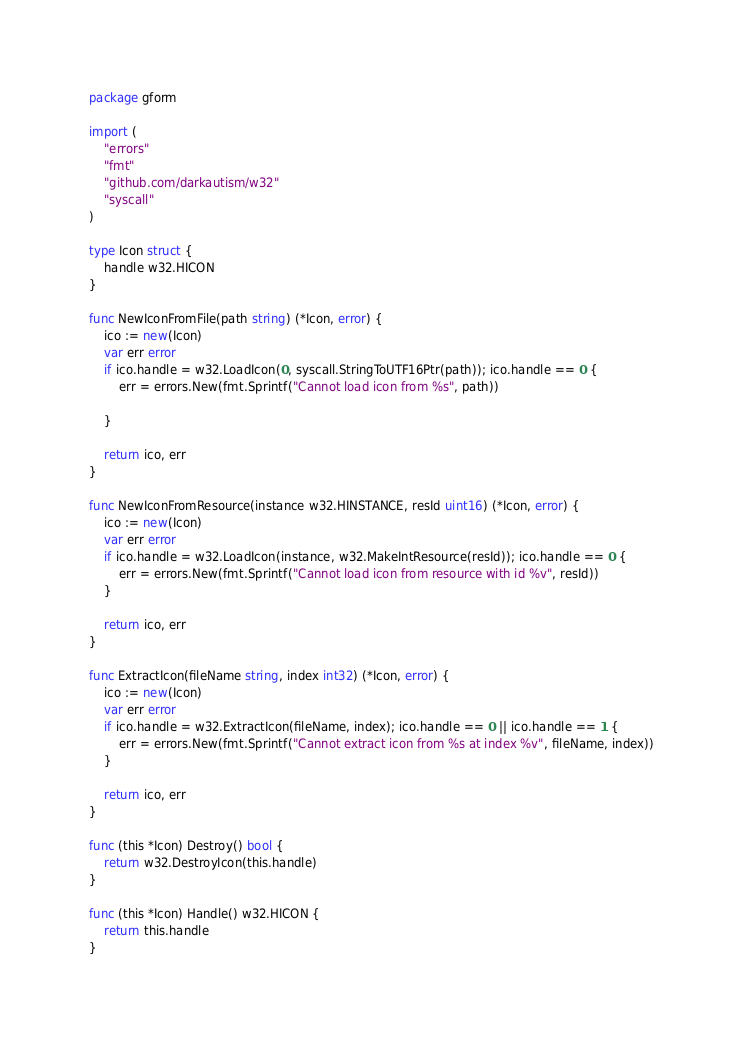Convert code to text. <code><loc_0><loc_0><loc_500><loc_500><_Go_>package gform

import (
	"errors"
	"fmt"
	"github.com/darkautism/w32"
	"syscall"
)

type Icon struct {
	handle w32.HICON
}

func NewIconFromFile(path string) (*Icon, error) {
	ico := new(Icon)
	var err error
	if ico.handle = w32.LoadIcon(0, syscall.StringToUTF16Ptr(path)); ico.handle == 0 {
		err = errors.New(fmt.Sprintf("Cannot load icon from %s", path))

	}

	return ico, err
}

func NewIconFromResource(instance w32.HINSTANCE, resId uint16) (*Icon, error) {
	ico := new(Icon)
	var err error
	if ico.handle = w32.LoadIcon(instance, w32.MakeIntResource(resId)); ico.handle == 0 {
		err = errors.New(fmt.Sprintf("Cannot load icon from resource with id %v", resId))
	}

	return ico, err
}

func ExtractIcon(fileName string, index int32) (*Icon, error) {
	ico := new(Icon)
	var err error
	if ico.handle = w32.ExtractIcon(fileName, index); ico.handle == 0 || ico.handle == 1 {
		err = errors.New(fmt.Sprintf("Cannot extract icon from %s at index %v", fileName, index))
	}

	return ico, err
}

func (this *Icon) Destroy() bool {
	return w32.DestroyIcon(this.handle)
}

func (this *Icon) Handle() w32.HICON {
	return this.handle
}
</code> 